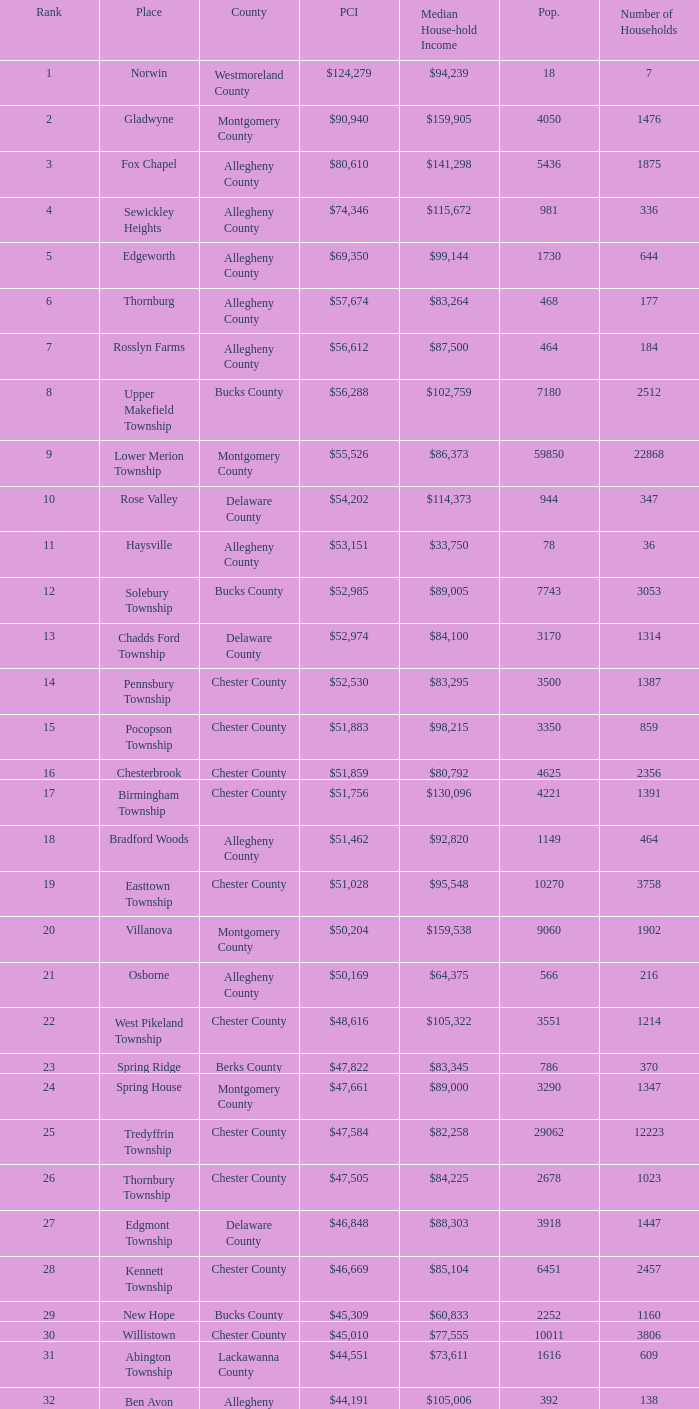What is the per capita income for Fayette County? $42,131. 